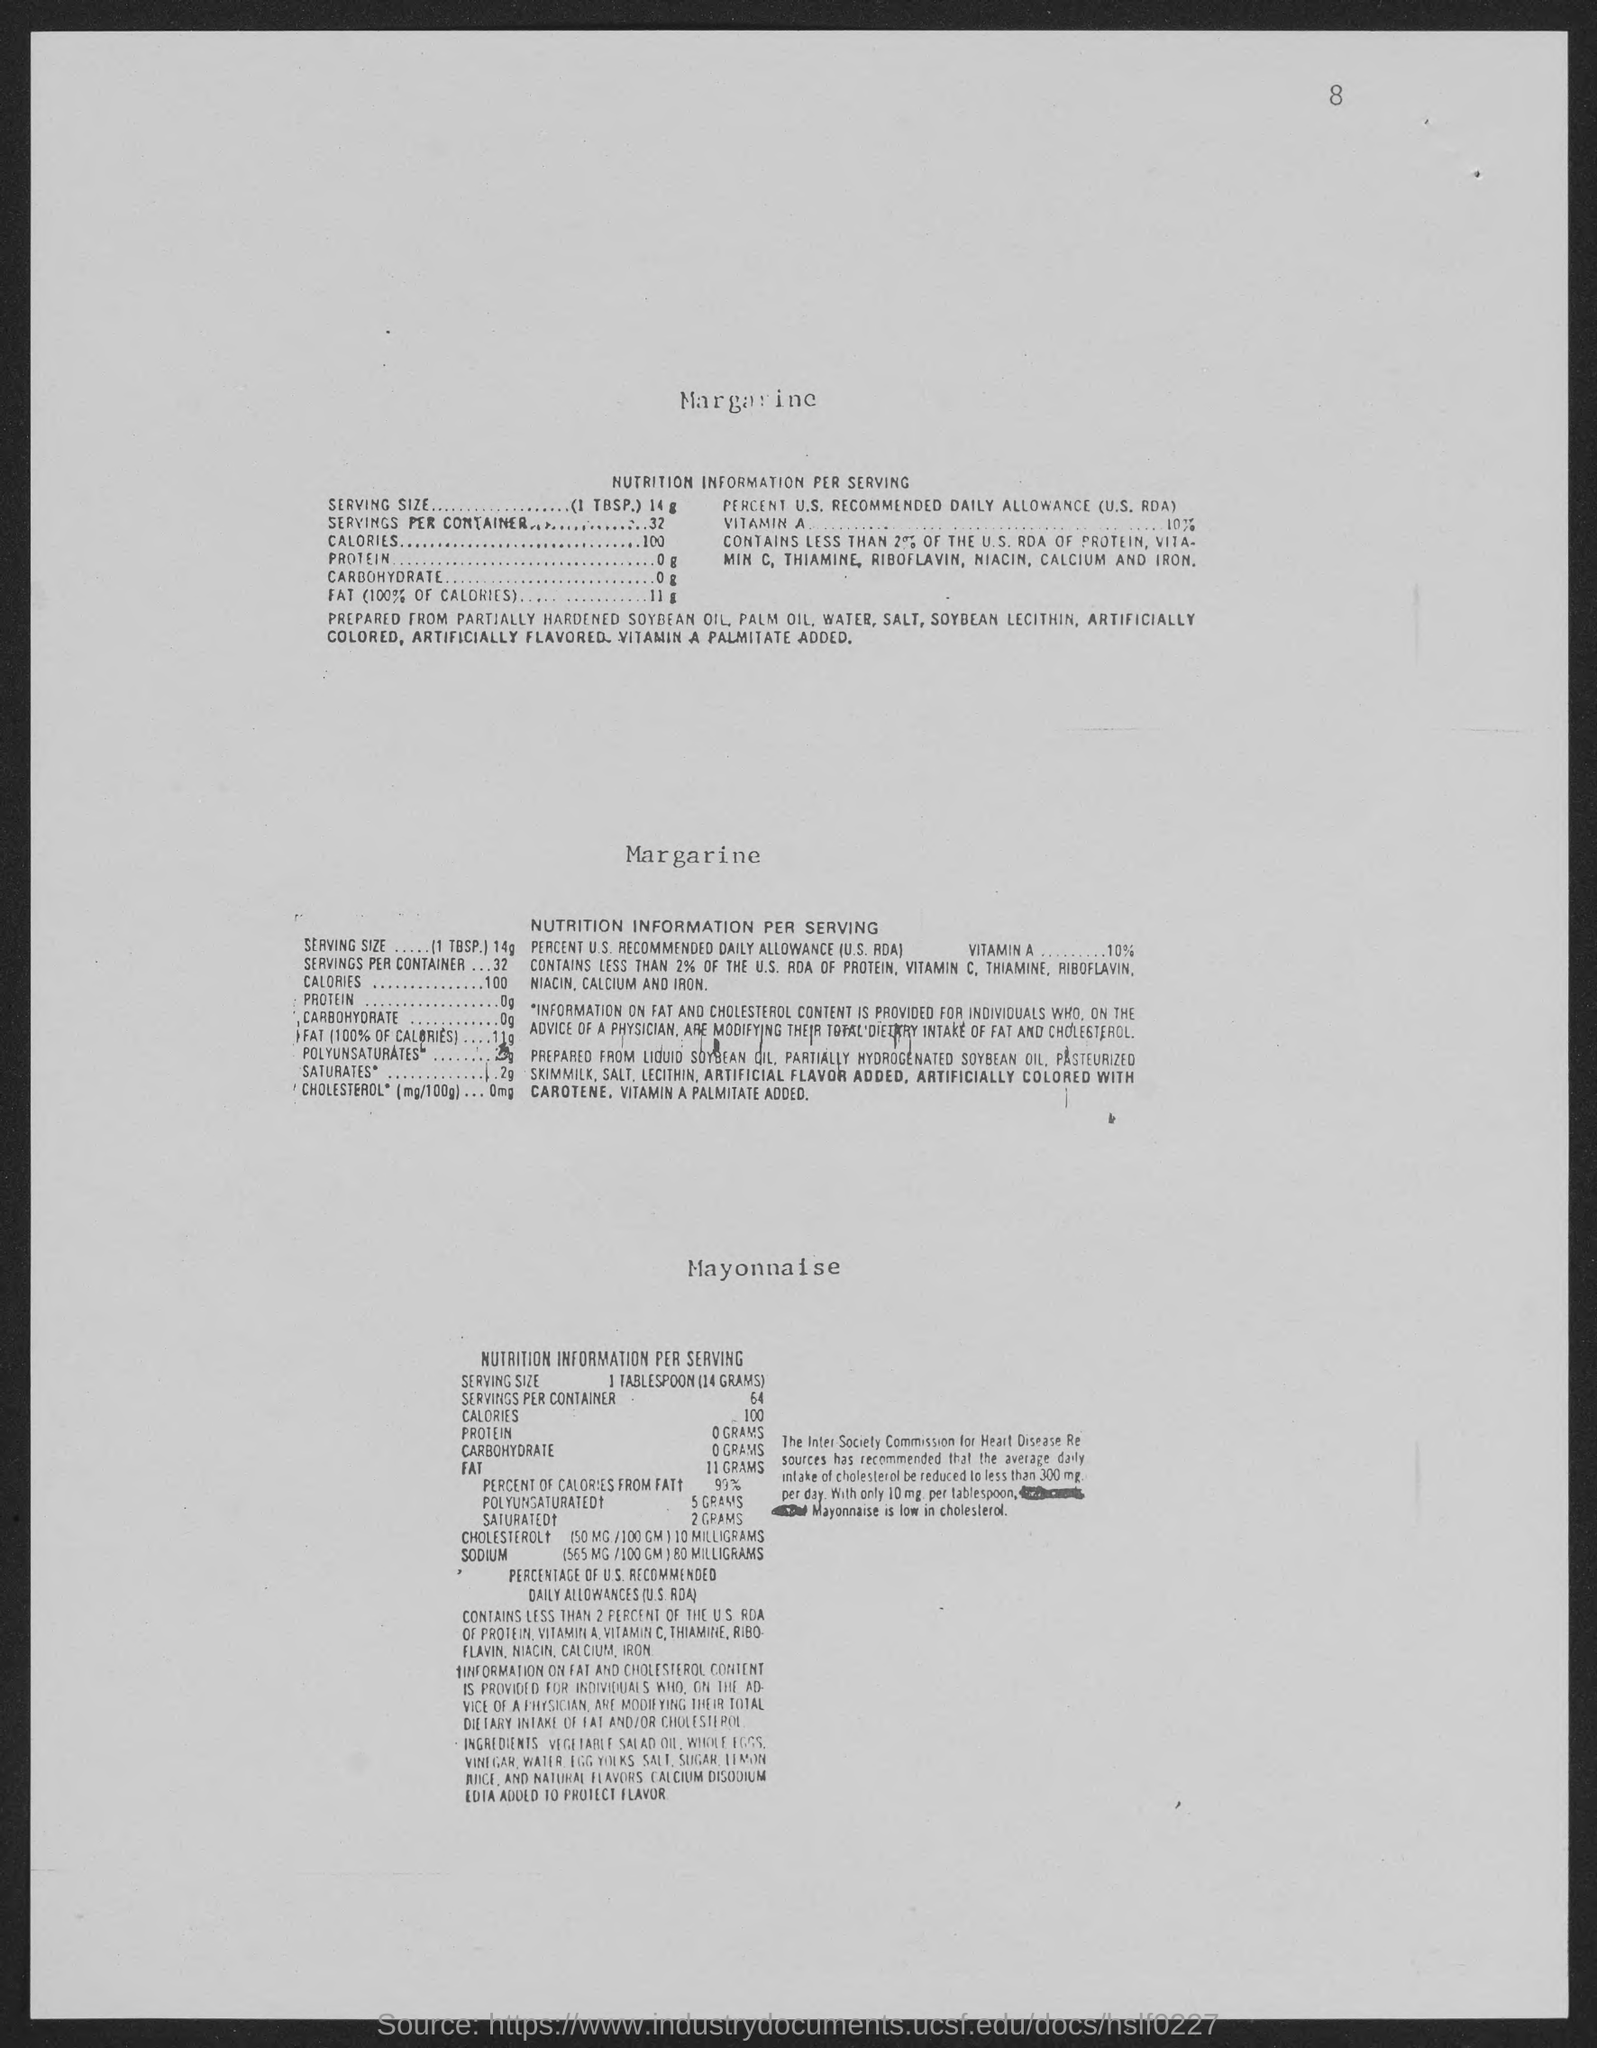What is the number at top-right corner of the page?
Provide a short and direct response. 8. 